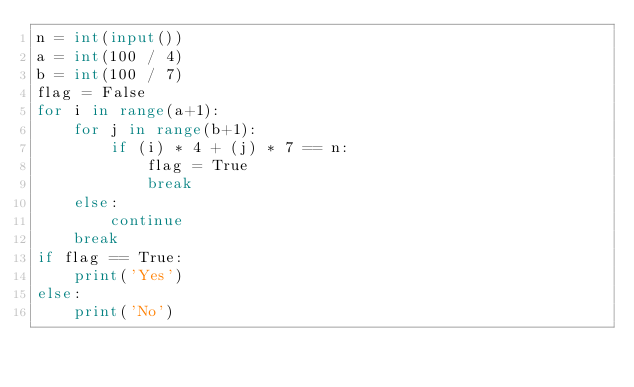<code> <loc_0><loc_0><loc_500><loc_500><_Python_>n = int(input())
a = int(100 / 4)
b = int(100 / 7)
flag = False
for i in range(a+1):
    for j in range(b+1):
        if (i) * 4 + (j) * 7 == n:
            flag = True
            break
    else:
        continue
    break
if flag == True:
    print('Yes')
else:
    print('No')</code> 